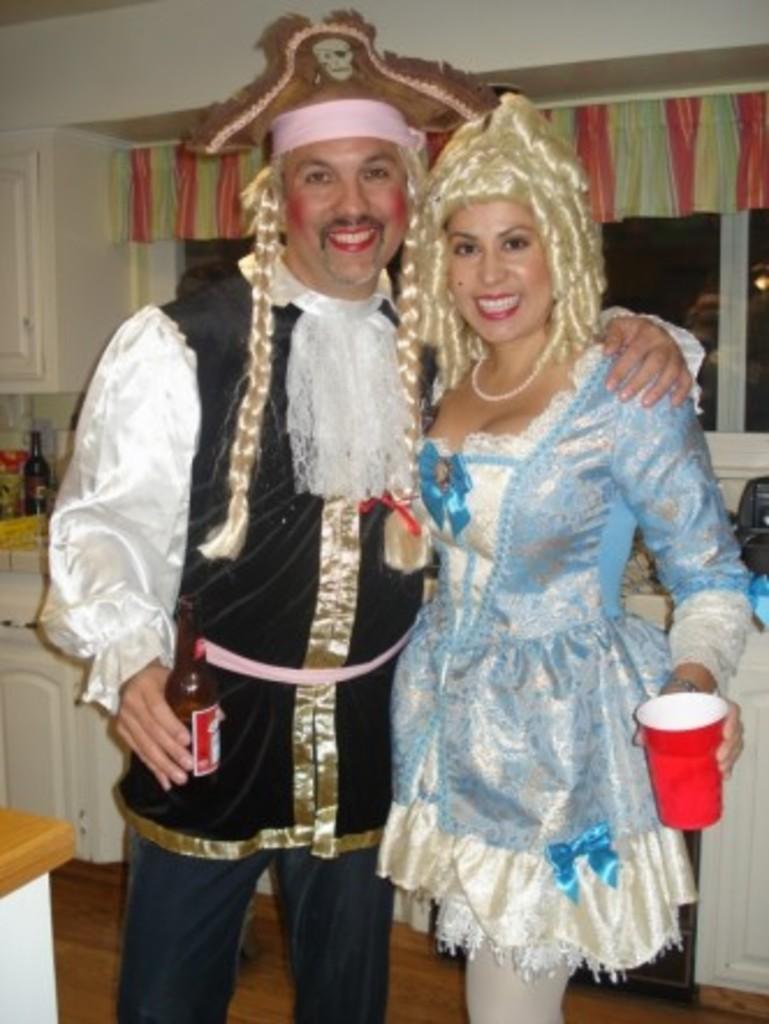In one or two sentences, can you explain what this image depicts? In this image we can see man and a woman holding beverage bottle and tumbler in their hands. In the background we can see cupboards, wall, curtain, windows and floor. 